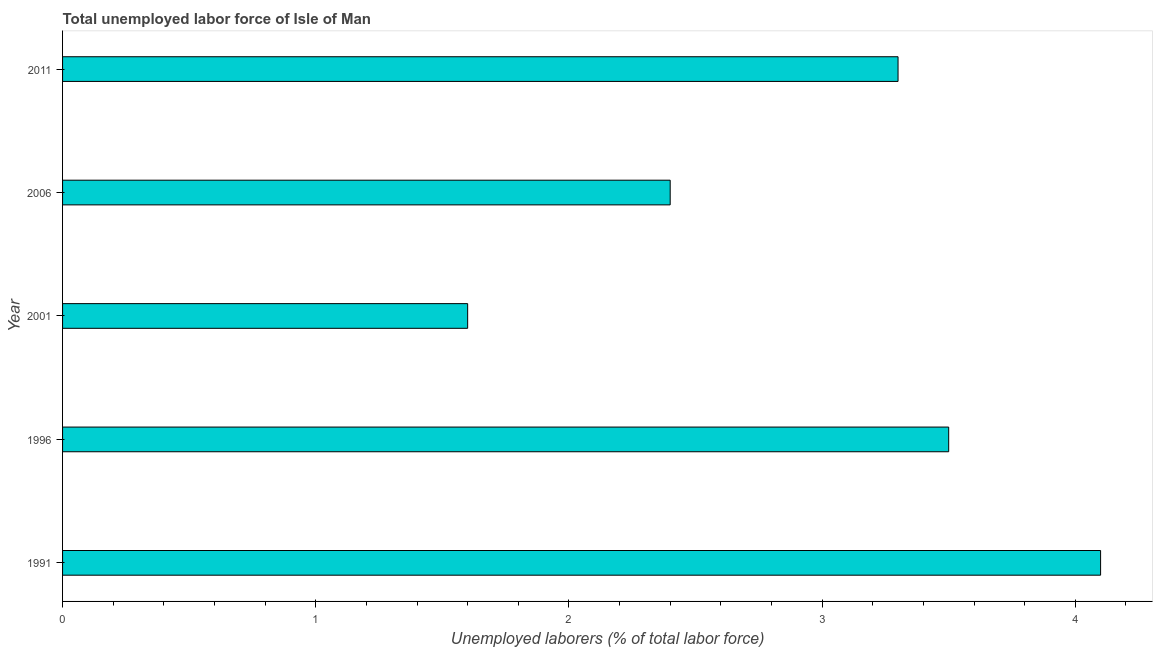What is the title of the graph?
Your answer should be very brief. Total unemployed labor force of Isle of Man. What is the label or title of the X-axis?
Make the answer very short. Unemployed laborers (% of total labor force). What is the total unemployed labour force in 1996?
Ensure brevity in your answer.  3.5. Across all years, what is the maximum total unemployed labour force?
Give a very brief answer. 4.1. Across all years, what is the minimum total unemployed labour force?
Ensure brevity in your answer.  1.6. What is the sum of the total unemployed labour force?
Offer a very short reply. 14.9. What is the average total unemployed labour force per year?
Keep it short and to the point. 2.98. What is the median total unemployed labour force?
Give a very brief answer. 3.3. In how many years, is the total unemployed labour force greater than 2 %?
Your answer should be very brief. 4. What is the ratio of the total unemployed labour force in 2001 to that in 2006?
Offer a terse response. 0.67. What is the difference between the highest and the second highest total unemployed labour force?
Offer a very short reply. 0.6. Are all the bars in the graph horizontal?
Provide a short and direct response. Yes. How many years are there in the graph?
Provide a short and direct response. 5. Are the values on the major ticks of X-axis written in scientific E-notation?
Your response must be concise. No. What is the Unemployed laborers (% of total labor force) of 1991?
Provide a succinct answer. 4.1. What is the Unemployed laborers (% of total labor force) of 2001?
Make the answer very short. 1.6. What is the Unemployed laborers (% of total labor force) in 2006?
Ensure brevity in your answer.  2.4. What is the Unemployed laborers (% of total labor force) in 2011?
Your answer should be very brief. 3.3. What is the difference between the Unemployed laborers (% of total labor force) in 1991 and 2001?
Ensure brevity in your answer.  2.5. What is the difference between the Unemployed laborers (% of total labor force) in 1991 and 2006?
Provide a succinct answer. 1.7. What is the difference between the Unemployed laborers (% of total labor force) in 1991 and 2011?
Offer a very short reply. 0.8. What is the difference between the Unemployed laborers (% of total labor force) in 1996 and 2006?
Offer a very short reply. 1.1. What is the difference between the Unemployed laborers (% of total labor force) in 1996 and 2011?
Keep it short and to the point. 0.2. What is the difference between the Unemployed laborers (% of total labor force) in 2001 and 2006?
Ensure brevity in your answer.  -0.8. What is the difference between the Unemployed laborers (% of total labor force) in 2006 and 2011?
Your response must be concise. -0.9. What is the ratio of the Unemployed laborers (% of total labor force) in 1991 to that in 1996?
Provide a short and direct response. 1.17. What is the ratio of the Unemployed laborers (% of total labor force) in 1991 to that in 2001?
Provide a succinct answer. 2.56. What is the ratio of the Unemployed laborers (% of total labor force) in 1991 to that in 2006?
Offer a terse response. 1.71. What is the ratio of the Unemployed laborers (% of total labor force) in 1991 to that in 2011?
Provide a short and direct response. 1.24. What is the ratio of the Unemployed laborers (% of total labor force) in 1996 to that in 2001?
Give a very brief answer. 2.19. What is the ratio of the Unemployed laborers (% of total labor force) in 1996 to that in 2006?
Give a very brief answer. 1.46. What is the ratio of the Unemployed laborers (% of total labor force) in 1996 to that in 2011?
Ensure brevity in your answer.  1.06. What is the ratio of the Unemployed laborers (% of total labor force) in 2001 to that in 2006?
Give a very brief answer. 0.67. What is the ratio of the Unemployed laborers (% of total labor force) in 2001 to that in 2011?
Make the answer very short. 0.48. What is the ratio of the Unemployed laborers (% of total labor force) in 2006 to that in 2011?
Ensure brevity in your answer.  0.73. 